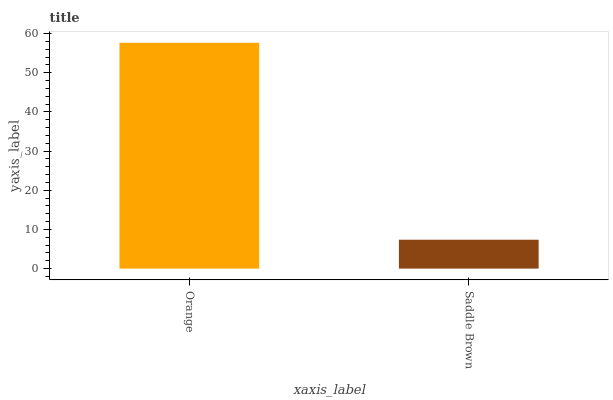Is Saddle Brown the minimum?
Answer yes or no. Yes. Is Orange the maximum?
Answer yes or no. Yes. Is Saddle Brown the maximum?
Answer yes or no. No. Is Orange greater than Saddle Brown?
Answer yes or no. Yes. Is Saddle Brown less than Orange?
Answer yes or no. Yes. Is Saddle Brown greater than Orange?
Answer yes or no. No. Is Orange less than Saddle Brown?
Answer yes or no. No. Is Orange the high median?
Answer yes or no. Yes. Is Saddle Brown the low median?
Answer yes or no. Yes. Is Saddle Brown the high median?
Answer yes or no. No. Is Orange the low median?
Answer yes or no. No. 